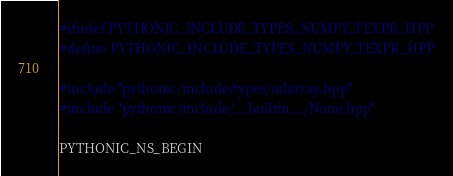Convert code to text. <code><loc_0><loc_0><loc_500><loc_500><_C++_>#ifndef PYTHONIC_INCLUDE_TYPES_NUMPY_TEXPR_HPP
#define PYTHONIC_INCLUDE_TYPES_NUMPY_TEXPR_HPP

#include "pythonic/include/types/ndarray.hpp"
#include "pythonic/include/__builtin__/None.hpp"

PYTHONIC_NS_BEGIN
</code> 